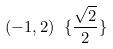Convert formula to latex. <formula><loc_0><loc_0><loc_500><loc_500>( - 1 , 2 ) \ \{ \frac { \sqrt { 2 } } { 2 } \}</formula> 